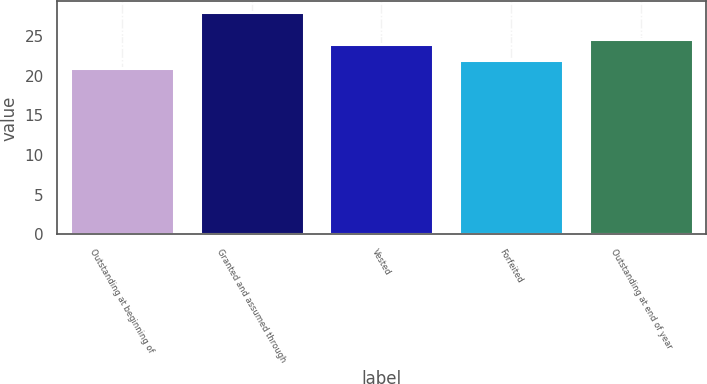Convert chart. <chart><loc_0><loc_0><loc_500><loc_500><bar_chart><fcel>Outstanding at beginning of<fcel>Granted and assumed through<fcel>Vested<fcel>Forfeited<fcel>Outstanding at end of year<nl><fcel>21<fcel>28<fcel>24<fcel>22<fcel>24.7<nl></chart> 